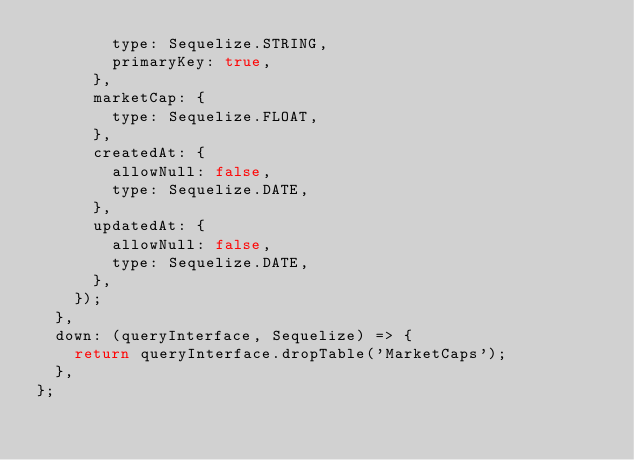Convert code to text. <code><loc_0><loc_0><loc_500><loc_500><_JavaScript_>        type: Sequelize.STRING,
        primaryKey: true,
      },
      marketCap: {
        type: Sequelize.FLOAT,
      },
      createdAt: {
        allowNull: false,
        type: Sequelize.DATE,
      },
      updatedAt: {
        allowNull: false,
        type: Sequelize.DATE,
      },
    });
  },
  down: (queryInterface, Sequelize) => {
    return queryInterface.dropTable('MarketCaps');
  },
};
</code> 